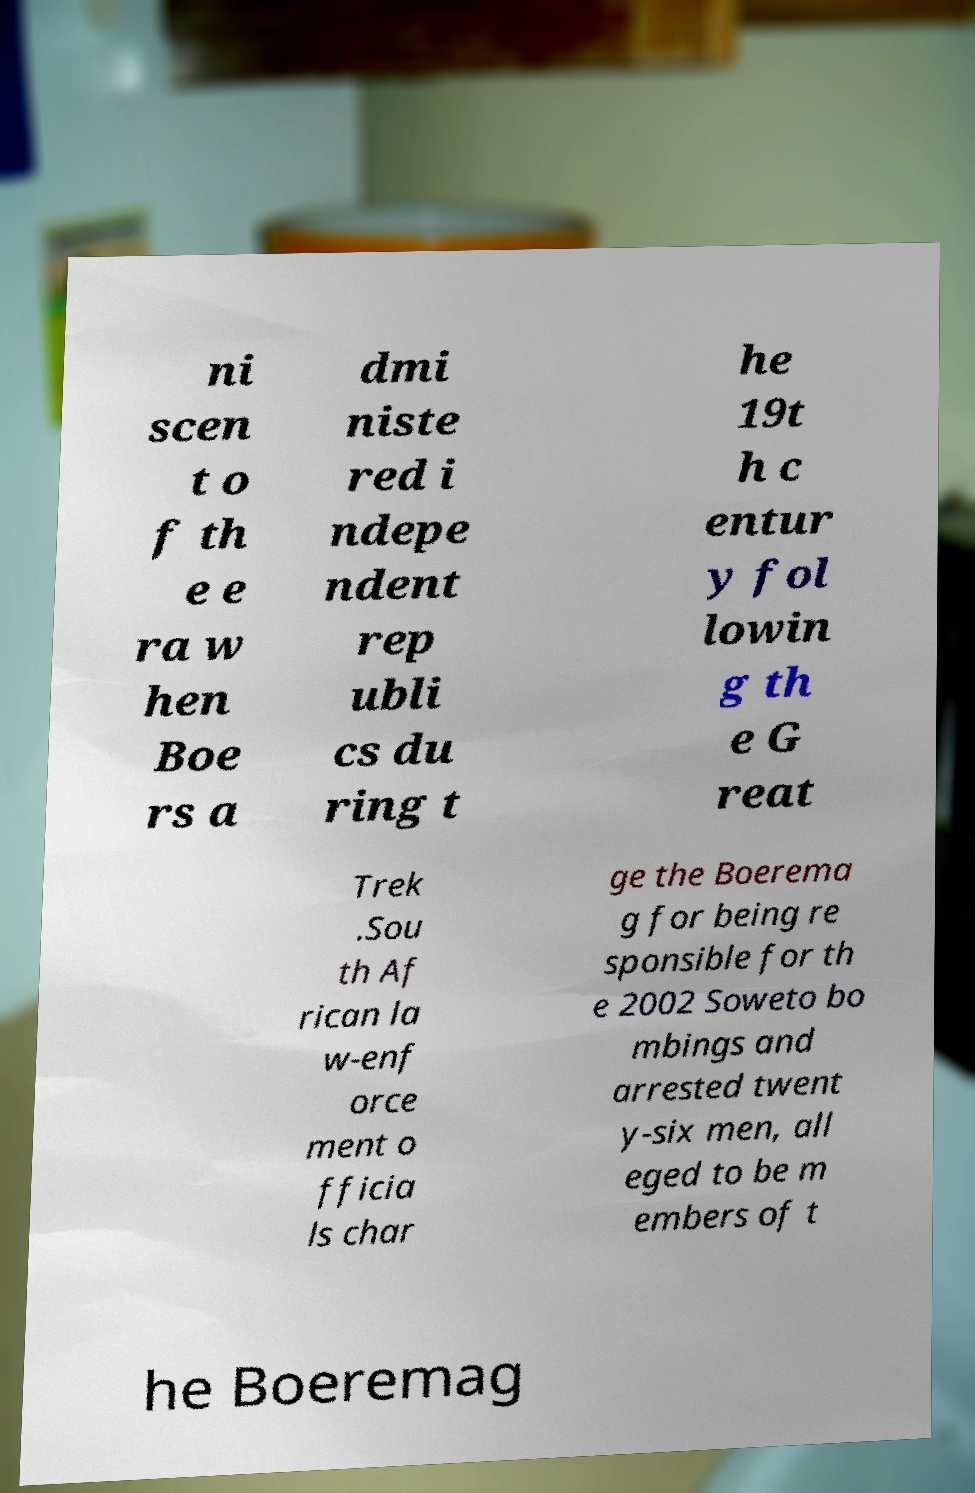Can you read and provide the text displayed in the image?This photo seems to have some interesting text. Can you extract and type it out for me? ni scen t o f th e e ra w hen Boe rs a dmi niste red i ndepe ndent rep ubli cs du ring t he 19t h c entur y fol lowin g th e G reat Trek .Sou th Af rican la w-enf orce ment o fficia ls char ge the Boerema g for being re sponsible for th e 2002 Soweto bo mbings and arrested twent y-six men, all eged to be m embers of t he Boeremag 